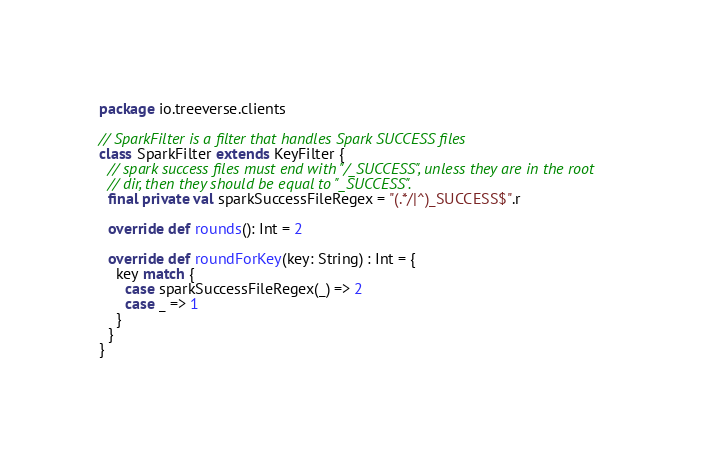<code> <loc_0><loc_0><loc_500><loc_500><_Scala_>package io.treeverse.clients

// SparkFilter is a filter that handles Spark SUCCESS files
class SparkFilter extends KeyFilter {
  // spark success files must end with "/_SUCCESS", unless they are in the root
  // dir, then they should be equal to "_SUCCESS".
  final private val sparkSuccessFileRegex = "(.*/|^)_SUCCESS$".r

  override def rounds(): Int = 2

  override def roundForKey(key: String) : Int = {
    key match {
      case sparkSuccessFileRegex(_) => 2
      case _ => 1
    }
  }
}
</code> 